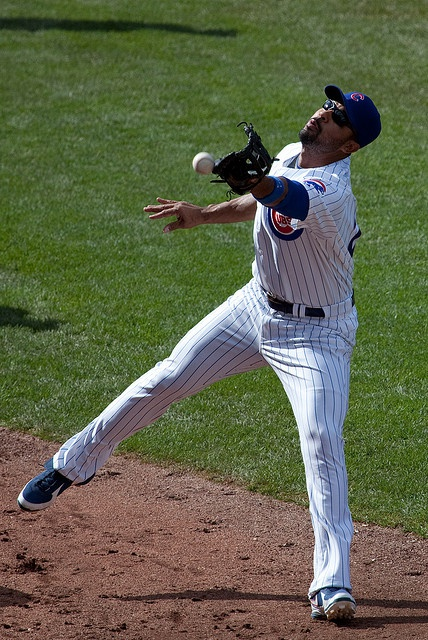Describe the objects in this image and their specific colors. I can see people in darkgreen, gray, black, and white tones, baseball glove in darkgreen, black, gray, and darkgray tones, and sports ball in darkgreen, gray, lightgray, and darkgray tones in this image. 